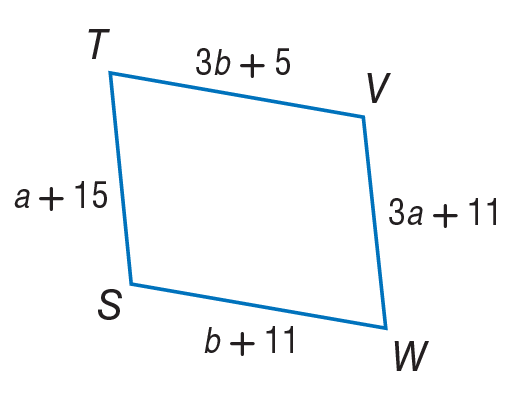Answer the mathemtical geometry problem and directly provide the correct option letter.
Question: Use parallelogram to find b.
Choices: A: 2 B: 3 C: 14 D: 17 B 